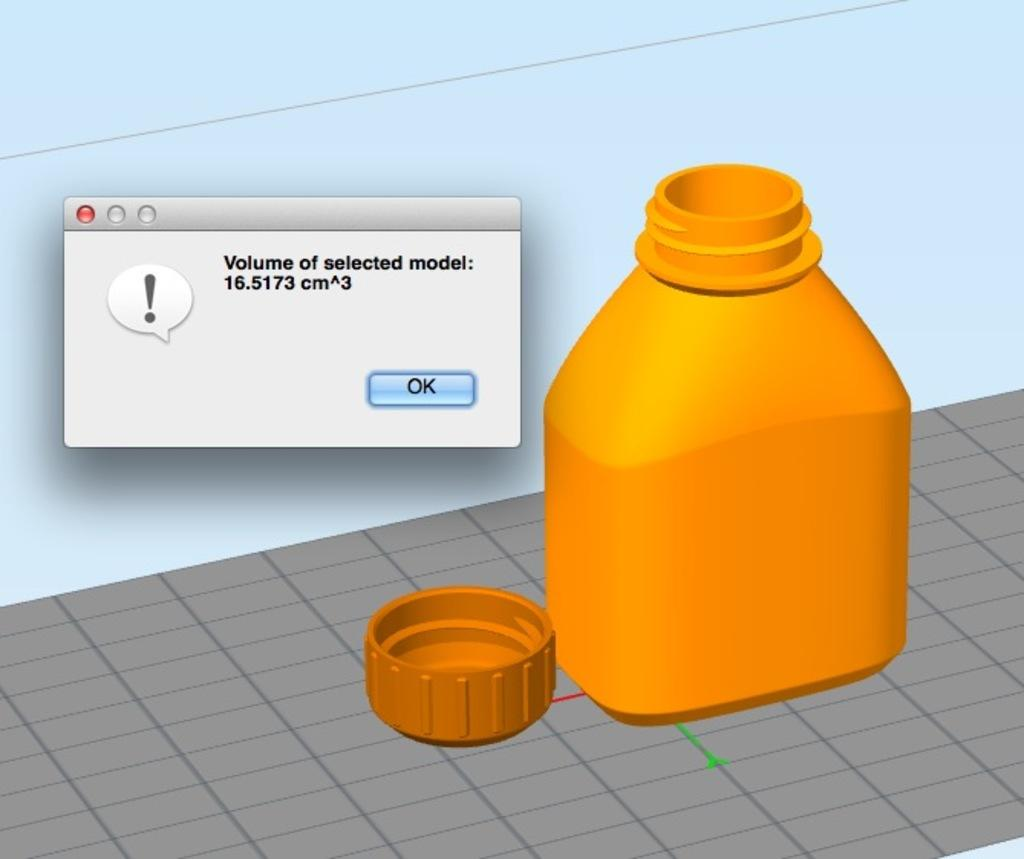<image>
Share a concise interpretation of the image provided. A yellow container with a alert about volume of the model. 